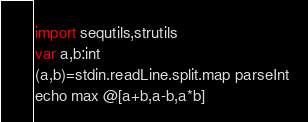Convert code to text. <code><loc_0><loc_0><loc_500><loc_500><_Nim_>import sequtils,strutils
var a,b:int
(a,b)=stdin.readLine.split.map parseInt
echo max @[a+b,a-b,a*b]</code> 